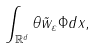<formula> <loc_0><loc_0><loc_500><loc_500>\int _ { \mathbb { R } ^ { d } } \theta \tilde { w } _ { \varepsilon } \Phi d x ,</formula> 